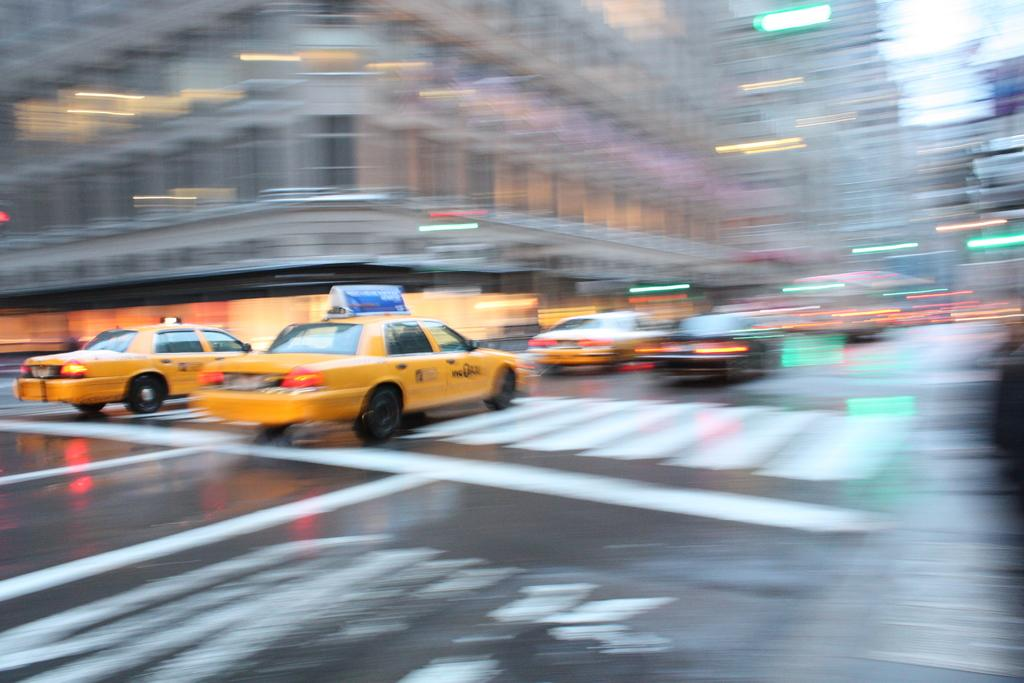What is the main feature in the center of the image? There is a road in the center of the image. What can be seen on the road? Vehicles are present on the road. What is visible in the background of the image? There are buildings in the background of the image. What type of bell can be heard ringing in the image? There is no bell present in the image, and therefore no sound can be heard. 